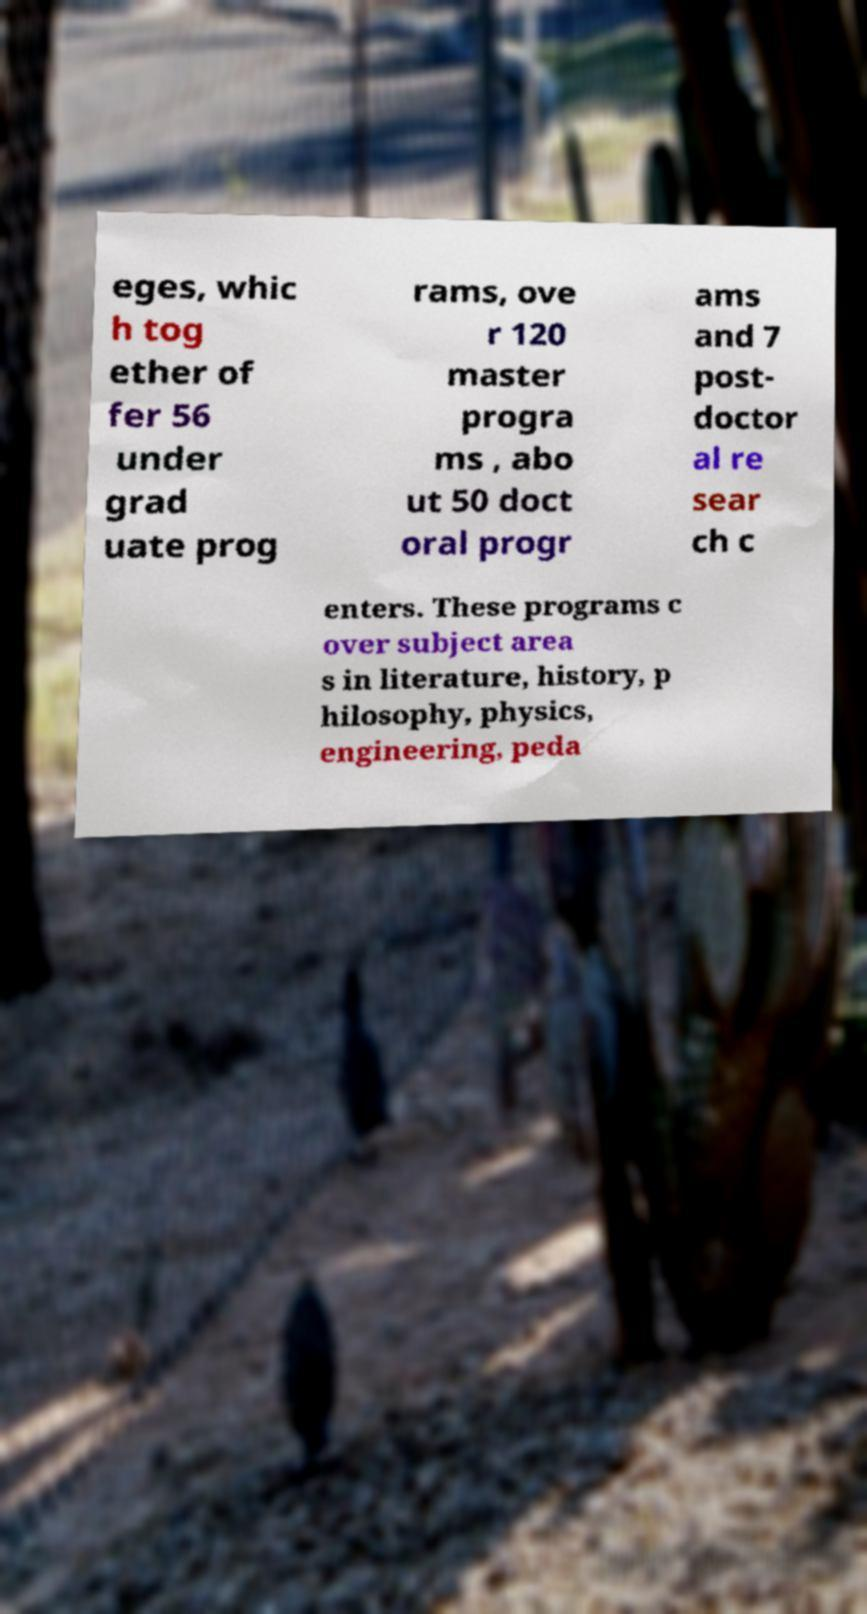For documentation purposes, I need the text within this image transcribed. Could you provide that? eges, whic h tog ether of fer 56 under grad uate prog rams, ove r 120 master progra ms , abo ut 50 doct oral progr ams and 7 post- doctor al re sear ch c enters. These programs c over subject area s in literature, history, p hilosophy, physics, engineering, peda 